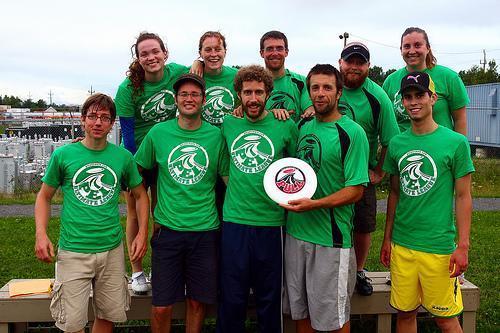How many frisbees are there?
Give a very brief answer. 1. 